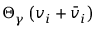Convert formula to latex. <formula><loc_0><loc_0><loc_500><loc_500>\Theta _ { \gamma } \left ( v _ { i } + { \bar { v } } _ { i } \right )</formula> 